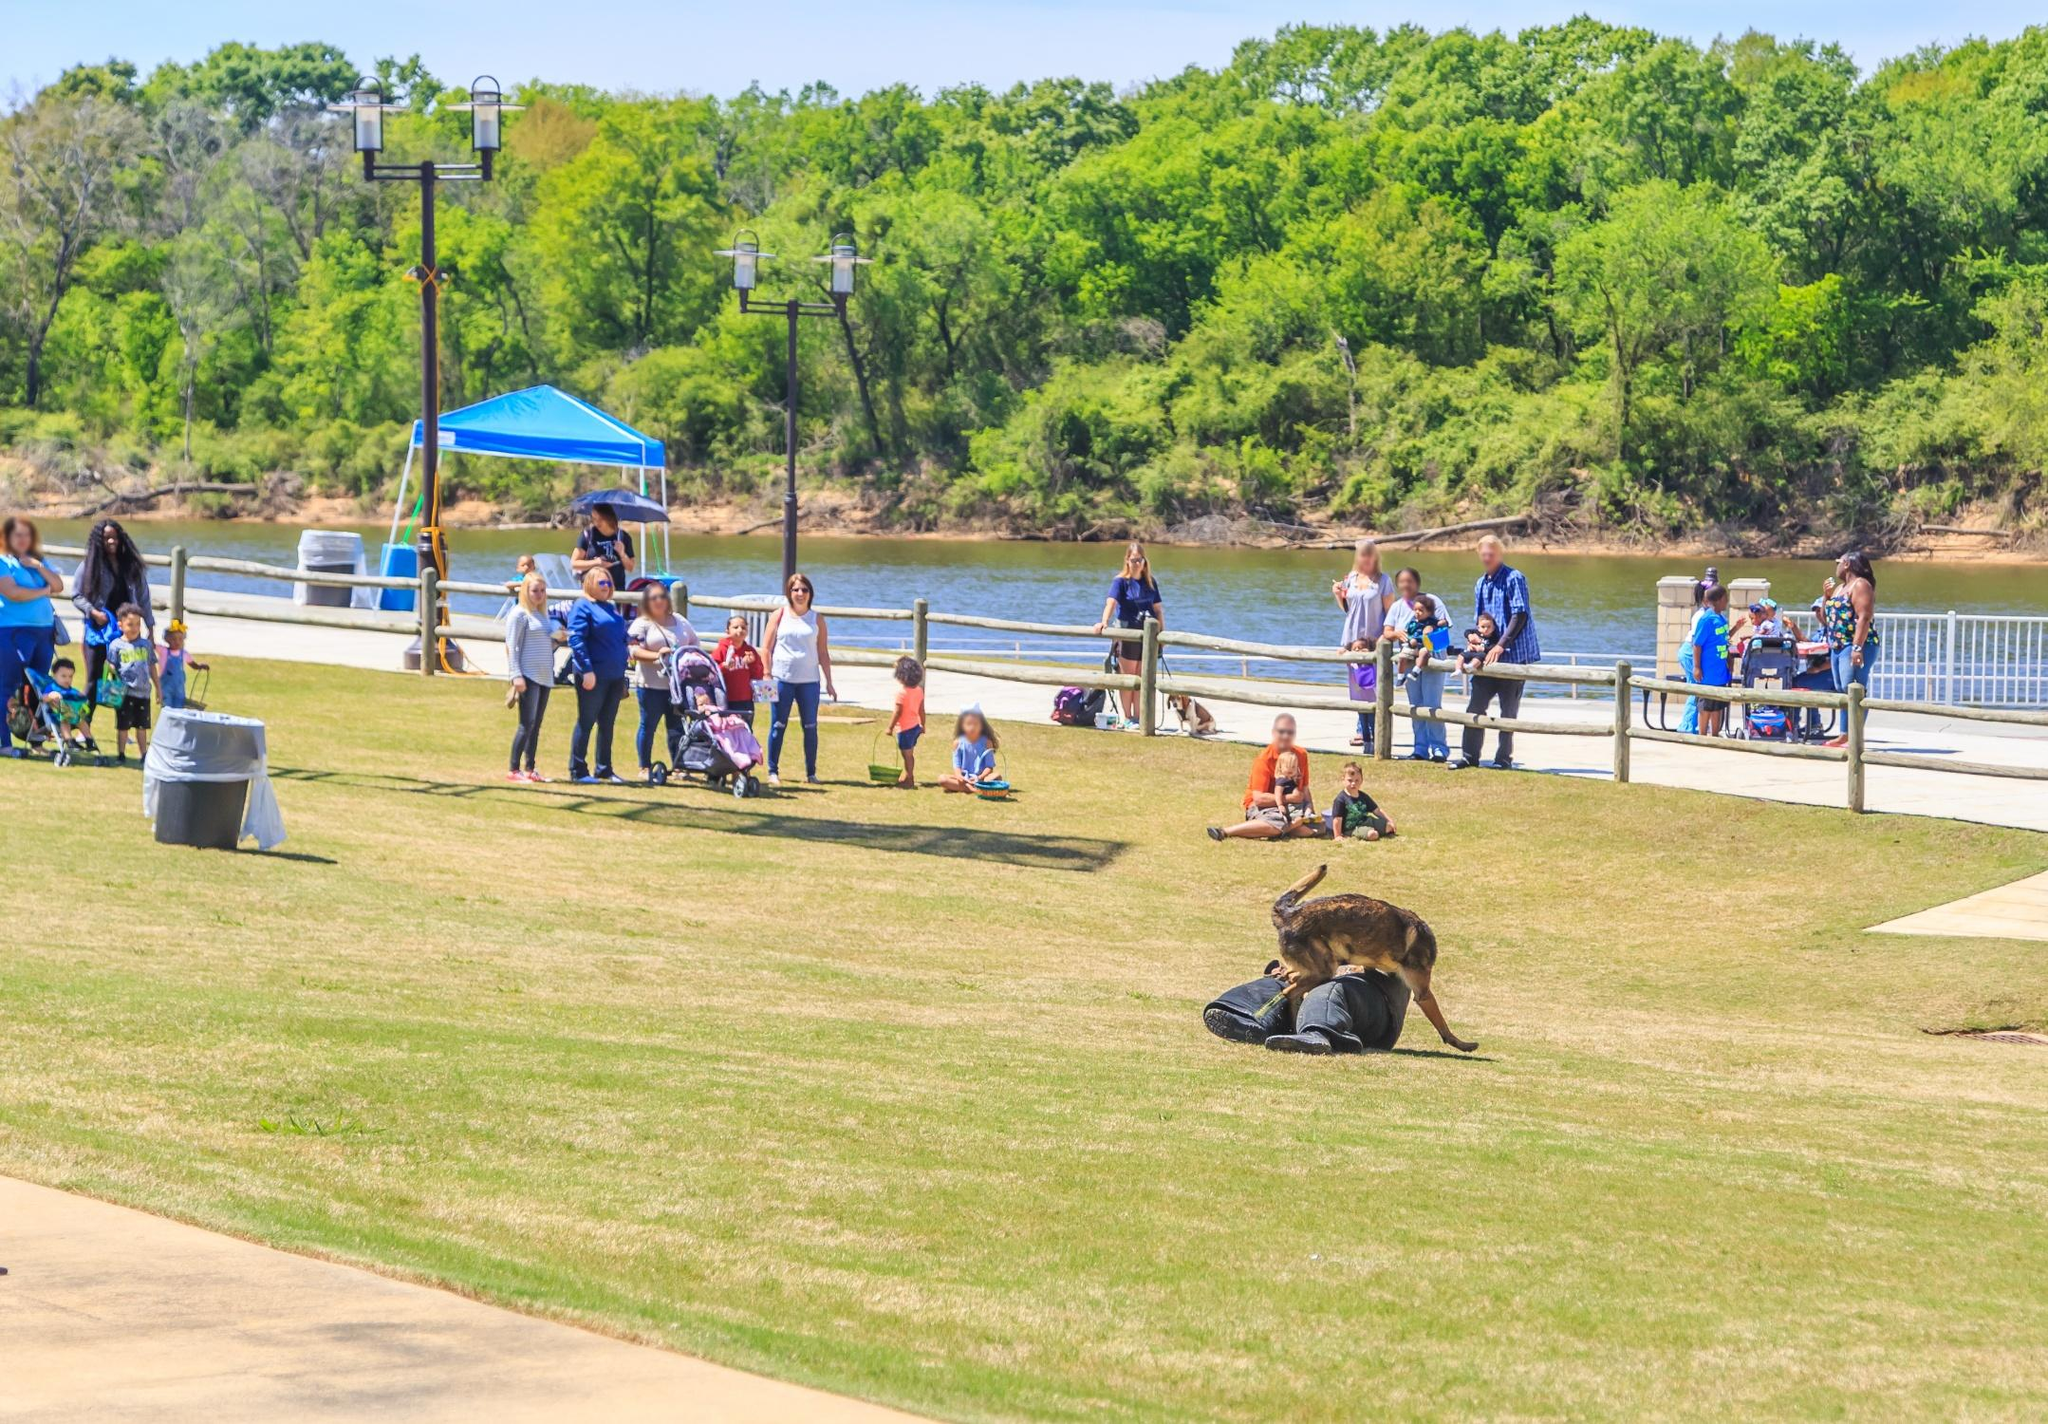If this park were located next to an amusement park instead of a river, how would the scene change? If this park were adjacent to an amusement park rather than a river, the scene would be significantly different. The tranquil riverside path would likely be replaced by bustling walkways filled with visitors heading toward rides and attractions. The background would be dominated by thrilling rides and colorful amusement park structures. The serene atmosphere would give way to the sounds of excitement, with laughter, screams of joy from roller coasters, and lively music filling the air. Visitors might be seen holding balloons, cotton candy, and amusement park maps, adding a festive and energetic vibe to the park scene. 